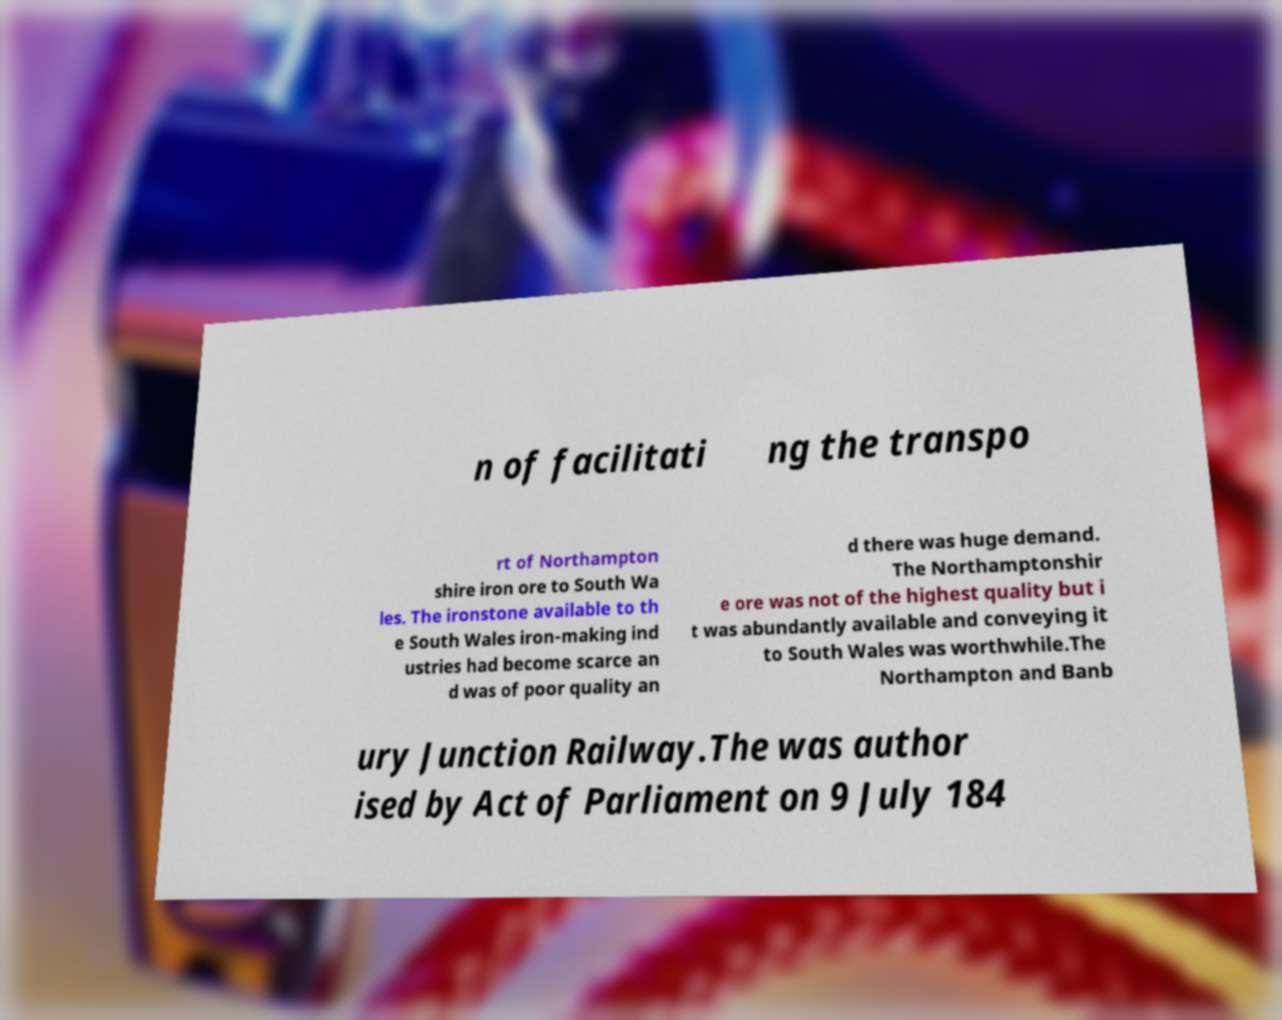Can you read and provide the text displayed in the image?This photo seems to have some interesting text. Can you extract and type it out for me? n of facilitati ng the transpo rt of Northampton shire iron ore to South Wa les. The ironstone available to th e South Wales iron-making ind ustries had become scarce an d was of poor quality an d there was huge demand. The Northamptonshir e ore was not of the highest quality but i t was abundantly available and conveying it to South Wales was worthwhile.The Northampton and Banb ury Junction Railway.The was author ised by Act of Parliament on 9 July 184 